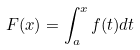<formula> <loc_0><loc_0><loc_500><loc_500>F ( x ) = \int _ { a } ^ { x } f ( t ) d t</formula> 